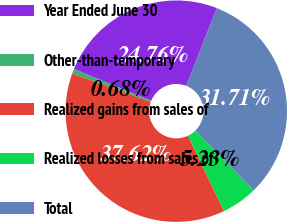Convert chart to OTSL. <chart><loc_0><loc_0><loc_500><loc_500><pie_chart><fcel>Year Ended June 30<fcel>Other-than-temporary<fcel>Realized gains from sales of<fcel>Realized losses from sales of<fcel>Total<nl><fcel>24.76%<fcel>0.68%<fcel>37.62%<fcel>5.23%<fcel>31.71%<nl></chart> 